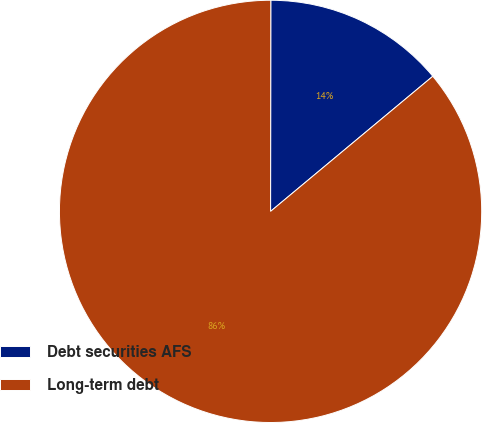Convert chart. <chart><loc_0><loc_0><loc_500><loc_500><pie_chart><fcel>Debt securities AFS<fcel>Long-term debt<nl><fcel>13.93%<fcel>86.07%<nl></chart> 